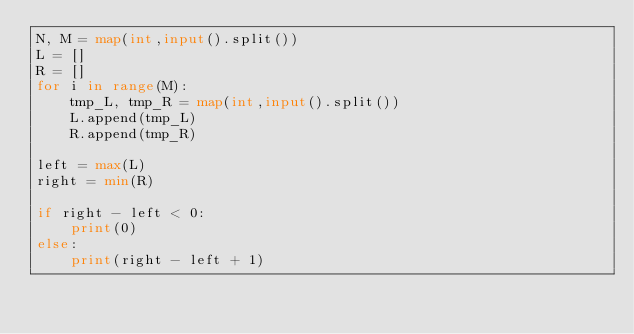<code> <loc_0><loc_0><loc_500><loc_500><_Python_>N, M = map(int,input().split())
L = []
R = []
for i in range(M):
    tmp_L, tmp_R = map(int,input().split())
    L.append(tmp_L)
    R.append(tmp_R)

left = max(L)
right = min(R)

if right - left < 0:
    print(0)
else:
    print(right - left + 1)</code> 